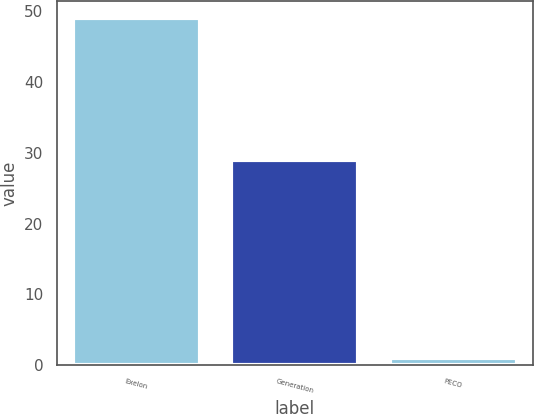Convert chart to OTSL. <chart><loc_0><loc_0><loc_500><loc_500><bar_chart><fcel>Exelon<fcel>Generation<fcel>PECO<nl><fcel>49<fcel>29<fcel>1<nl></chart> 